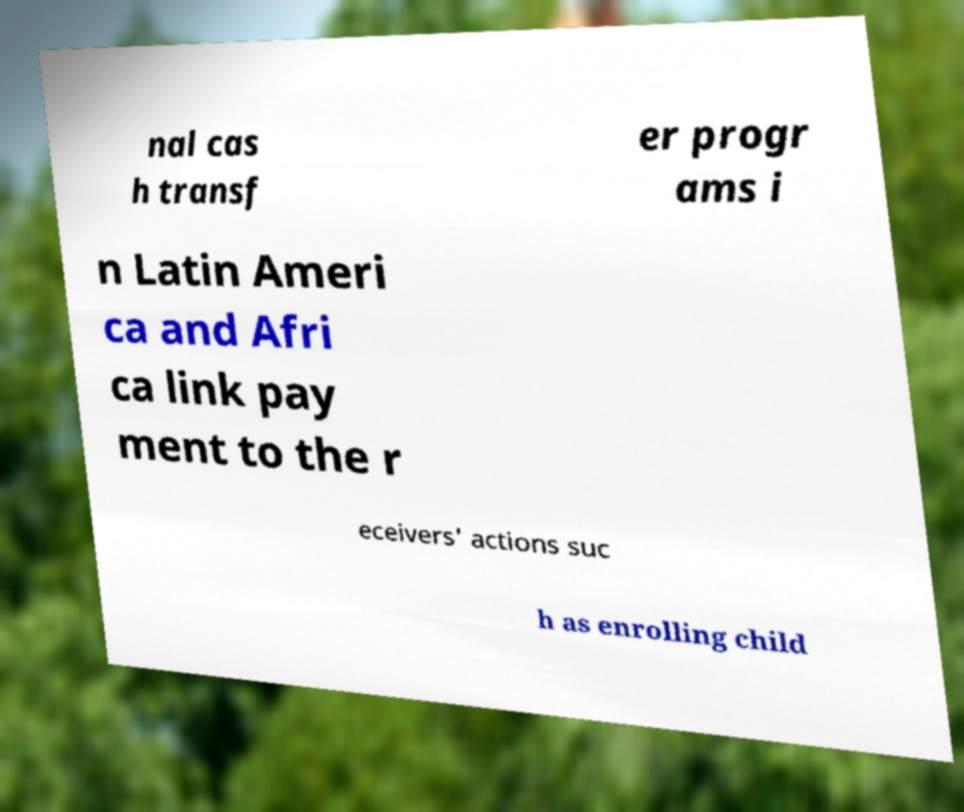Please identify and transcribe the text found in this image. nal cas h transf er progr ams i n Latin Ameri ca and Afri ca link pay ment to the r eceivers' actions suc h as enrolling child 